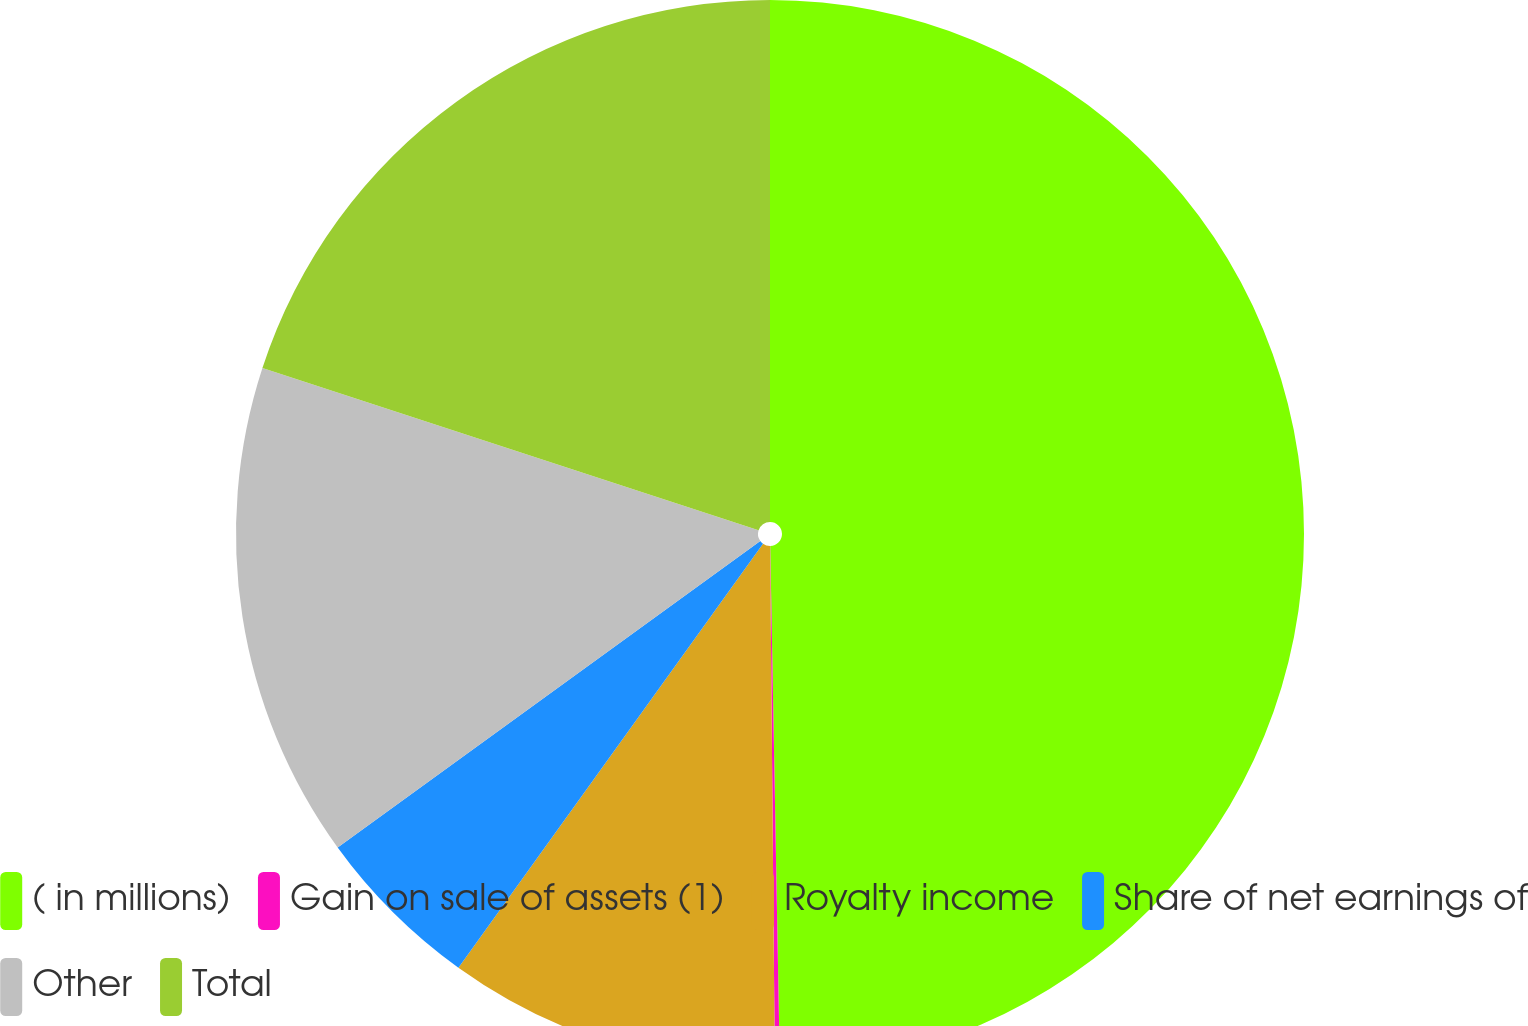Convert chart to OTSL. <chart><loc_0><loc_0><loc_500><loc_500><pie_chart><fcel>( in millions)<fcel>Gain on sale of assets (1)<fcel>Royalty income<fcel>Share of net earnings of<fcel>Other<fcel>Total<nl><fcel>49.7%<fcel>0.15%<fcel>10.06%<fcel>5.1%<fcel>15.01%<fcel>19.97%<nl></chart> 